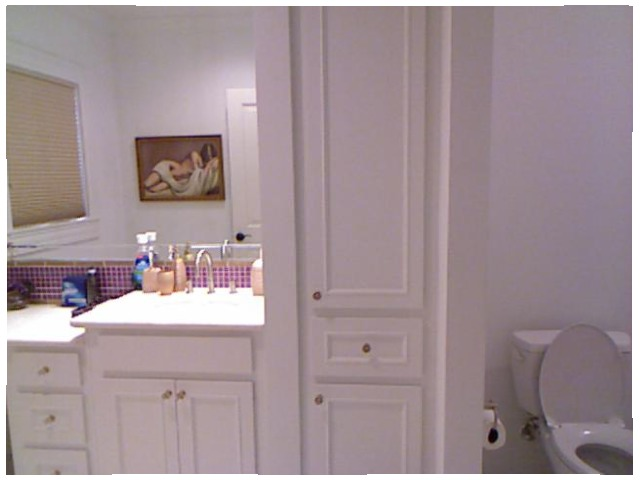<image>
Is there a tap under the photo frame? No. The tap is not positioned under the photo frame. The vertical relationship between these objects is different. Is the door in front of the table? No. The door is not in front of the table. The spatial positioning shows a different relationship between these objects. 